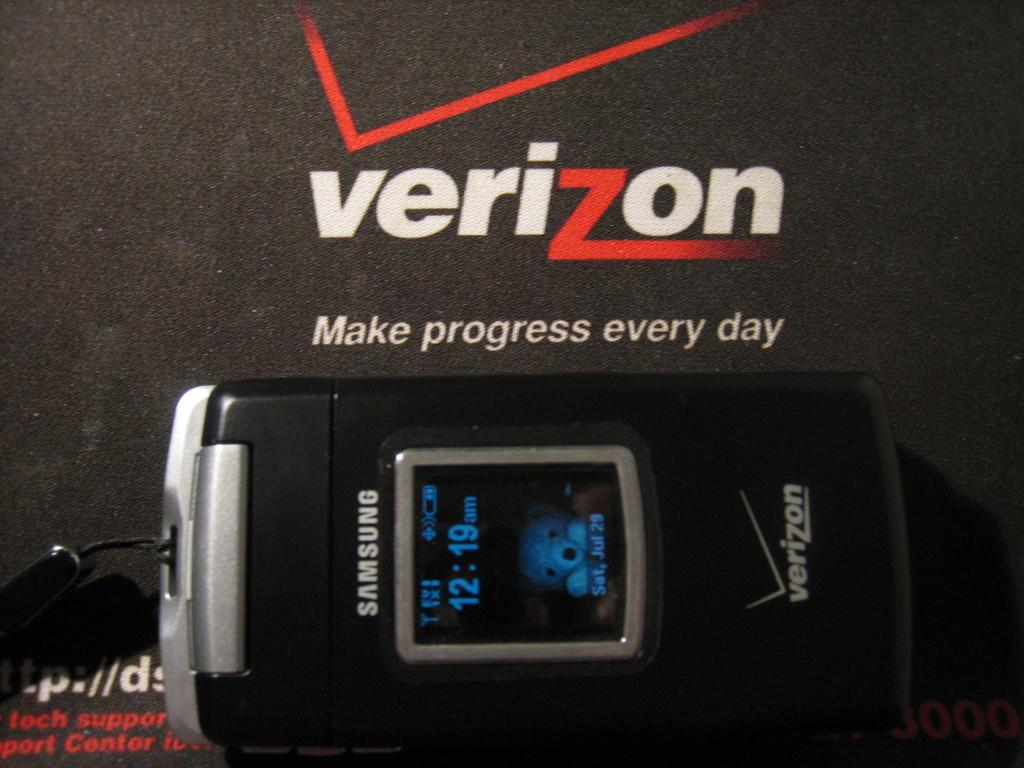Provide a one-sentence caption for the provided image. A Samsung Flip Phone with Verizon brand on it. 